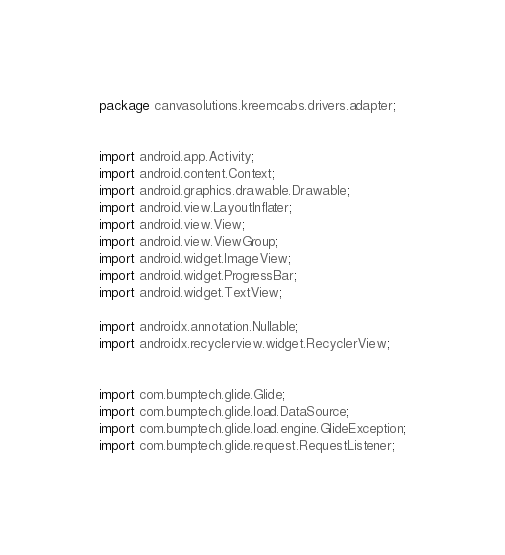Convert code to text. <code><loc_0><loc_0><loc_500><loc_500><_Java_>package canvasolutions.kreemcabs.drivers.adapter;


import android.app.Activity;
import android.content.Context;
import android.graphics.drawable.Drawable;
import android.view.LayoutInflater;
import android.view.View;
import android.view.ViewGroup;
import android.widget.ImageView;
import android.widget.ProgressBar;
import android.widget.TextView;

import androidx.annotation.Nullable;
import androidx.recyclerview.widget.RecyclerView;


import com.bumptech.glide.Glide;
import com.bumptech.glide.load.DataSource;
import com.bumptech.glide.load.engine.GlideException;
import com.bumptech.glide.request.RequestListener;</code> 